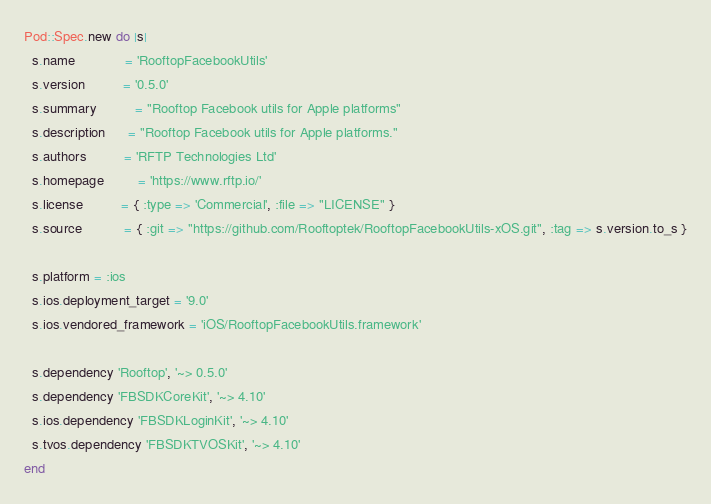<code> <loc_0><loc_0><loc_500><loc_500><_Ruby_>Pod::Spec.new do |s|
  s.name             = 'RooftopFacebookUtils'
  s.version          = '0.5.0'
  s.summary          = "Rooftop Facebook utils for Apple platforms"
  s.description      = "Rooftop Facebook utils for Apple platforms."
  s.authors          = 'RFTP Technologies Ltd'
  s.homepage         = 'https://www.rftp.io/'
  s.license          = { :type => 'Commercial', :file => "LICENSE" }
  s.source           = { :git => "https://github.com/Rooftoptek/RooftopFacebookUtils-xOS.git", :tag => s.version.to_s }

  s.platform = :ios
  s.ios.deployment_target = '9.0'
  s.ios.vendored_framework = 'iOS/RooftopFacebookUtils.framework'

  s.dependency 'Rooftop', '~> 0.5.0'
  s.dependency 'FBSDKCoreKit', '~> 4.10'
  s.ios.dependency 'FBSDKLoginKit', '~> 4.10'
  s.tvos.dependency 'FBSDKTVOSKit', '~> 4.10'
end
</code> 